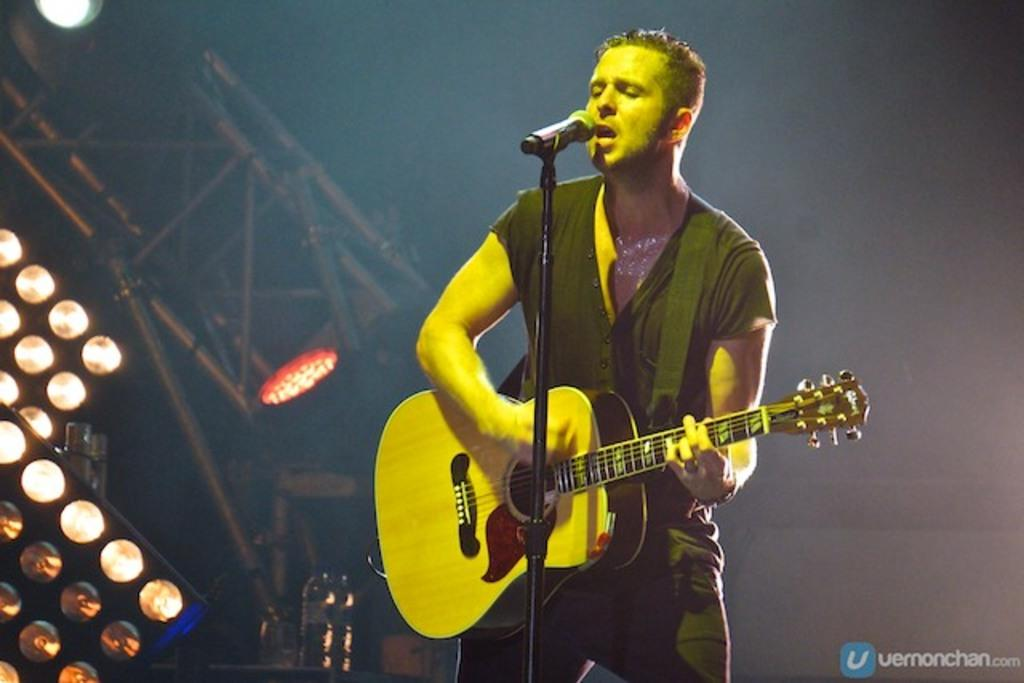What is the man in the image doing? The man is playing guitar and singing in the image. How is the man's voice being amplified? The man is using a microphone in the image. What can be seen in the background of the image? There are poles and lights in the background of the image. Are there any veils visible in the image? No, there are no veils present in the image. What type of fuel is being used by the man to power his performance? The image does not provide any information about the use of fuel, as the man is performing with a guitar and microphone. 